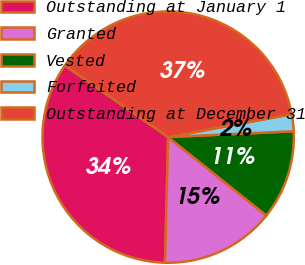<chart> <loc_0><loc_0><loc_500><loc_500><pie_chart><fcel>Outstanding at January 1<fcel>Granted<fcel>Vested<fcel>Forfeited<fcel>Outstanding at December 31<nl><fcel>34.24%<fcel>14.67%<fcel>11.47%<fcel>2.18%<fcel>37.44%<nl></chart> 